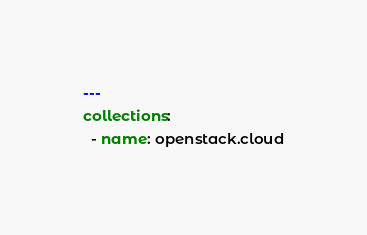Convert code to text. <code><loc_0><loc_0><loc_500><loc_500><_YAML_>---
collections:
  - name: openstack.cloud</code> 